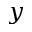Convert formula to latex. <formula><loc_0><loc_0><loc_500><loc_500>y</formula> 